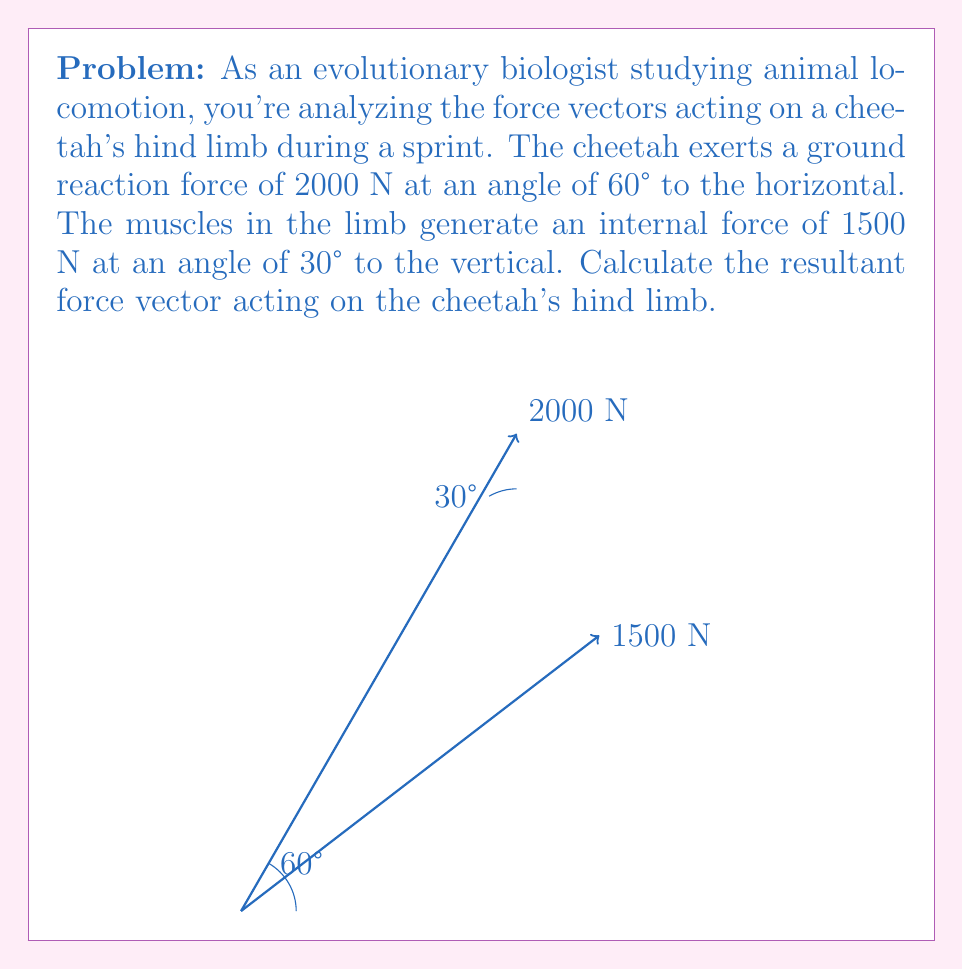What is the answer to this math problem? To solve this problem, we need to follow these steps:

1) First, let's break down each force into its horizontal and vertical components:

   For the 2000 N force:
   $F_x = 2000 \cos 60° = 2000 \cdot 0.5 = 1000$ N
   $F_y = 2000 \sin 60° = 2000 \cdot 0.866 = 1732$ N

   For the 1500 N force:
   $F_x = 1500 \sin 30° = 1500 \cdot 0.5 = 750$ N
   $F_y = 1500 \cos 30° = 1500 \cdot 0.866 = 1299$ N

2) Now, we sum the x and y components separately:
   $\sum F_x = 1000 + 750 = 1750$ N
   $\sum F_y = 1732 + 1299 = 3031$ N

3) The resultant force vector can be calculated using the Pythagorean theorem:

   $F_{resultant} = \sqrt{(\sum F_x)^2 + (\sum F_y)^2}$
   $F_{resultant} = \sqrt{1750^2 + 3031^2} = \sqrt{3062500 + 9187161} = \sqrt{12249661} \approx 3500$ N

4) The angle of the resultant force with respect to the horizontal can be calculated using arctangent:

   $\theta = \tan^{-1}(\frac{\sum F_y}{\sum F_x}) = \tan^{-1}(\frac{3031}{1750}) \approx 60.0°$

Therefore, the resultant force vector is approximately 3500 N at an angle of 60.0° to the horizontal.
Answer: $\vec{F}_{resultant} \approx 3500$ N $\angle 60.0°$ 